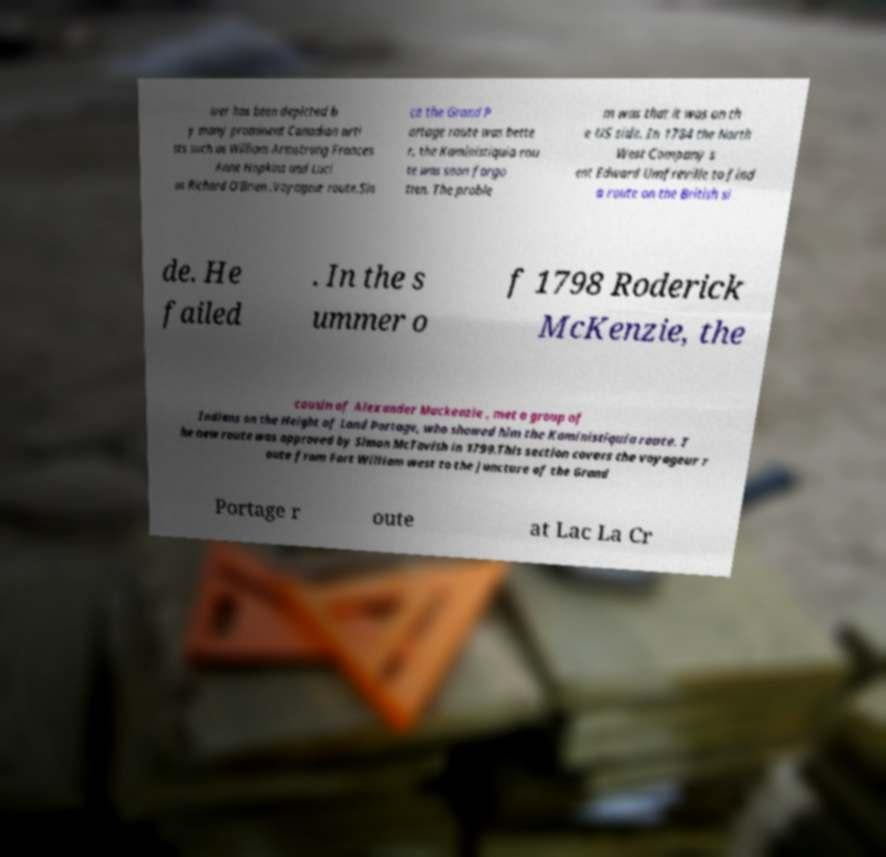Could you assist in decoding the text presented in this image and type it out clearly? iver has been depicted b y many prominent Canadian arti sts such as William Armstrong Frances Anne Hopkins and Luci us Richard O'Brien .Voyageur route.Sin ce the Grand P ortage route was bette r, the Kaministiquia rou te was soon forgo tten. The proble m was that it was on th e US side. In 1784 the North West Company s ent Edward Umfreville to find a route on the British si de. He failed . In the s ummer o f 1798 Roderick McKenzie, the cousin of Alexander Mackenzie , met a group of Indians on the Height of Land Portage, who showed him the Kaministiquia route. T he new route was approved by Simon McTavish in 1799.This section covers the voyageur r oute from Fort William west to the juncture of the Grand Portage r oute at Lac La Cr 